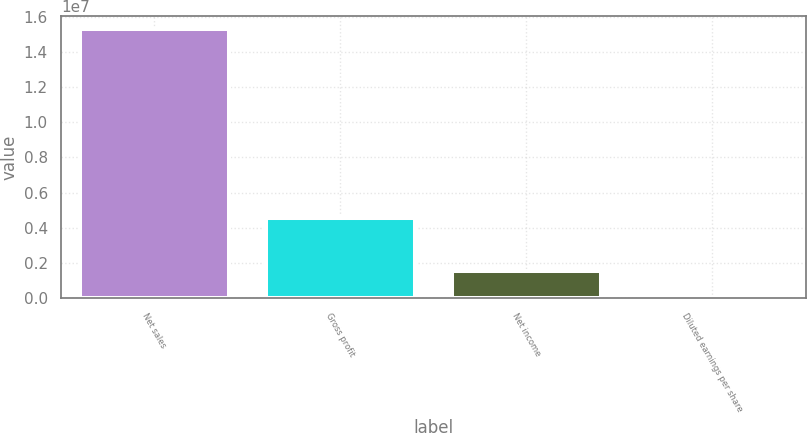Convert chart. <chart><loc_0><loc_0><loc_500><loc_500><bar_chart><fcel>Net sales<fcel>Gross profit<fcel>Net income<fcel>Diluted earnings per share<nl><fcel>1.528e+07<fcel>4.55585e+06<fcel>1.52801e+06<fcel>4.63<nl></chart> 